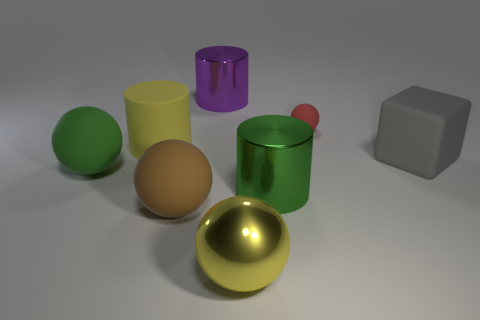Are there more metal objects that are behind the big yellow shiny thing than large gray rubber blocks in front of the big brown matte sphere? Upon inspection of the image, there are no metal objects visible behind the large, shiny yellow sphere. As for large gray rubber blocks, there is one gray block in the scene, but it is not positioned in front of the large brown sphere, which is, in fact, a matte ball. Due to the absence of metal objects behind the yellow sphere and only one gray block present, which isn't in front of the brown sphere, the comparison posed in the question can't be accurately assessed according to the described spatial layout. 